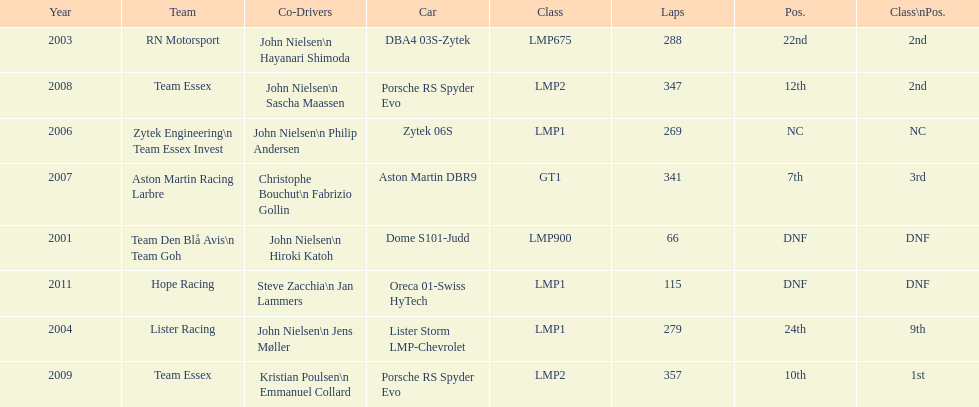What model car was the most used? Porsche RS Spyder. 